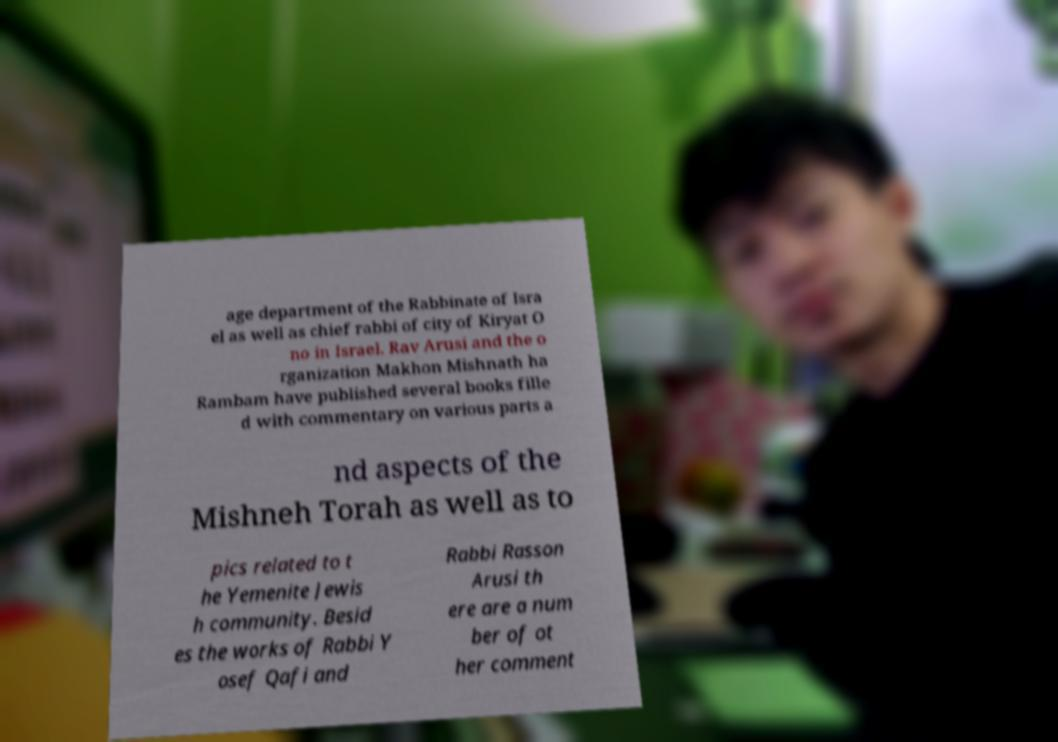For documentation purposes, I need the text within this image transcribed. Could you provide that? age department of the Rabbinate of Isra el as well as chief rabbi of city of Kiryat O no in Israel. Rav Arusi and the o rganization Makhon Mishnath ha Rambam have published several books fille d with commentary on various parts a nd aspects of the Mishneh Torah as well as to pics related to t he Yemenite Jewis h community. Besid es the works of Rabbi Y osef Qafi and Rabbi Rasson Arusi th ere are a num ber of ot her comment 